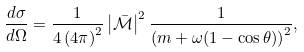<formula> <loc_0><loc_0><loc_500><loc_500>\frac { d \sigma } { d \Omega } = \frac { 1 } { 4 \left ( 4 \pi \right ) ^ { 2 } } \left | \mathcal { \bar { M } } \right | ^ { 2 } \frac { 1 } { \left ( m + \omega ( 1 - \cos \theta ) \right ) ^ { 2 } } ,</formula> 